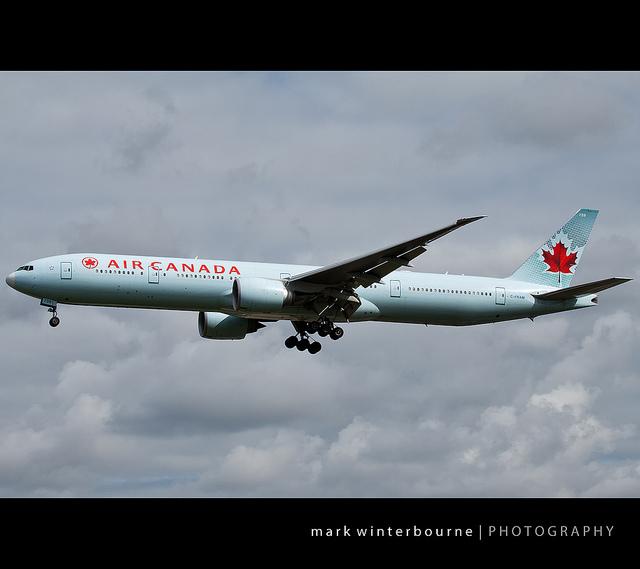What company owns this plane?
Quick response, please. Air canada. Is this a little plane?
Give a very brief answer. No. What country is this airline based out of?
Keep it brief. Canada. What is the name of the company?
Keep it brief. Air canada. What kind of leaf is on the tail of plane?
Concise answer only. Maple. What is the full name of this airline?
Write a very short answer. Air canada. What color is this air Canada jet?
Keep it brief. White. What country is plane from?
Give a very brief answer. Canada. How many big clouds can be seen behind the plane?
Keep it brief. 1. Which airline is this?
Write a very short answer. Air canada. 